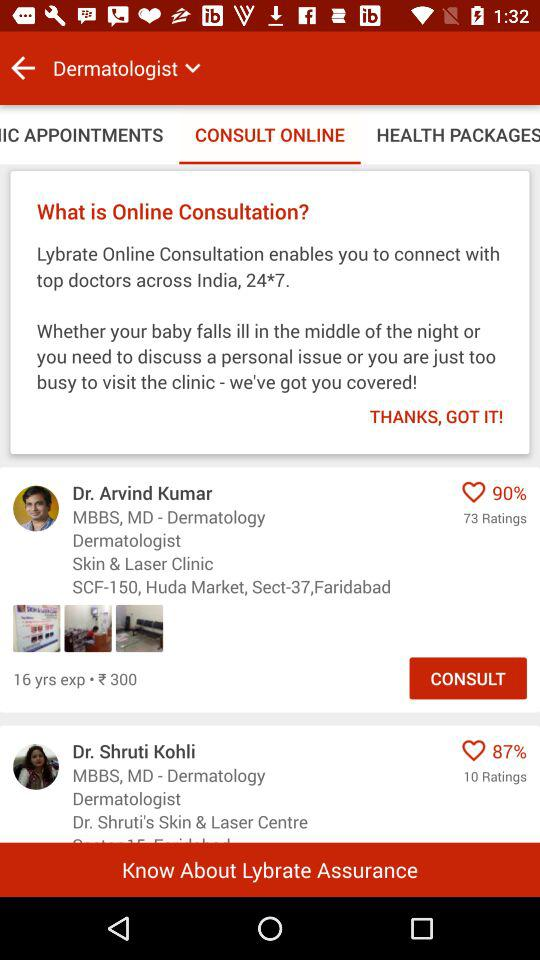What are the ratings for Dr. Shruti Kohli? The rating is 87 percent. 